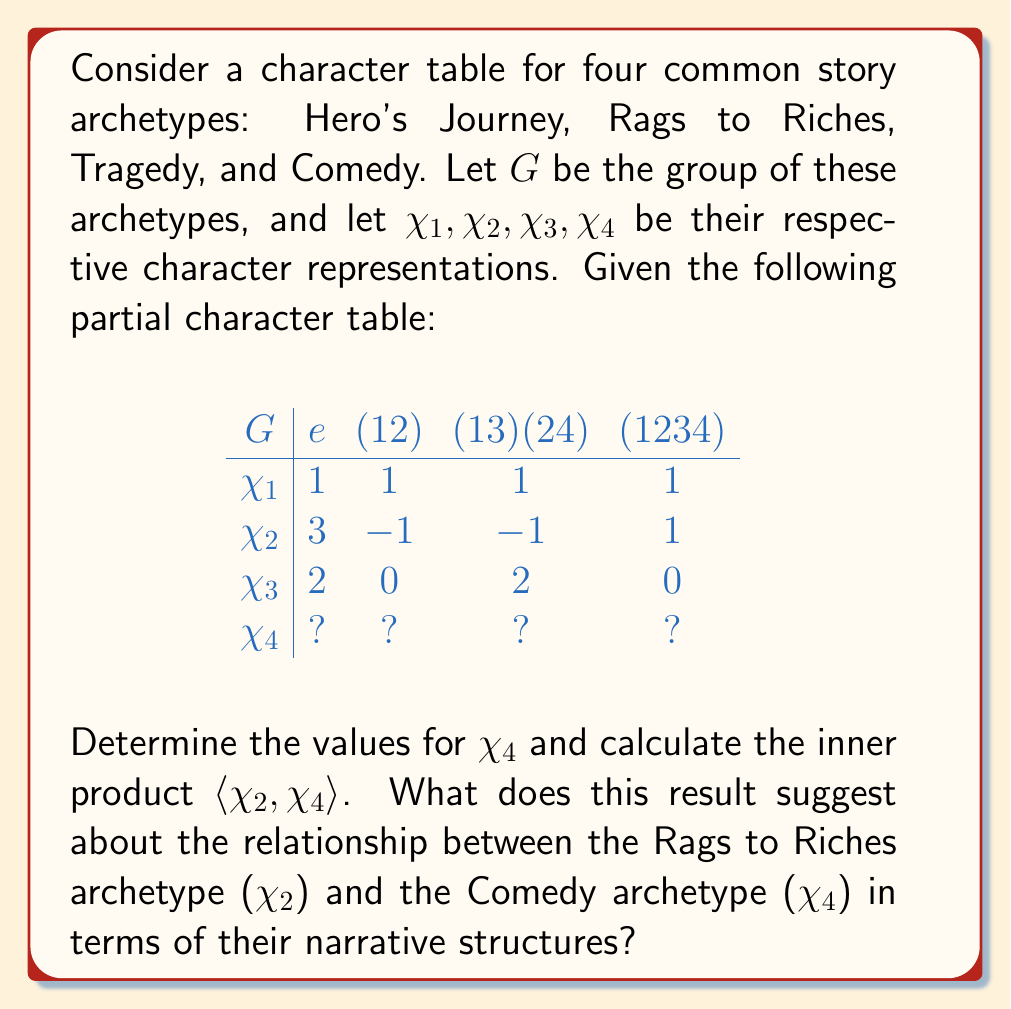Can you answer this question? To solve this problem, we'll follow these steps:

1) First, we need to complete the character table for $\chi_4$. We can do this using the orthogonality relations of characters:

   a) The sum of squares of the dimensions of irreducible representations equals the order of the group:
      $1^2 + 3^2 + 2^2 + (\chi_4(e))^2 = |G| = 4$
      So, $\chi_4(e) = 2$

   b) The sum of characters in each column (except the first) must be zero:
      For (12): $1 + (-1) + 0 + \chi_4((12)) = 0$, so $\chi_4((12)) = 0$
      For (13)(24): $1 + (-1) + 2 + \chi_4((13)(24)) = 0$, so $\chi_4((13)(24)) = -2$
      For (1234): $1 + 1 + 0 + \chi_4((1234)) = 0$, so $\chi_4((1234)) = -2$

2) Now we have the complete character table:

   $$
   \begin{array}{c|cccc}
   G & e & (12) & (13)(24) & (1234) \\
   \hline
   \chi_1 & 1 & 1 & 1 & 1 \\
   \chi_2 & 3 & -1 & -1 & 1 \\
   \chi_3 & 2 & 0 & 2 & 0 \\
   \chi_4 & 2 & 0 & -2 & -2 \\
   \end{array}
   $$

3) To calculate the inner product $\langle \chi_2, \chi_4 \rangle$, we use the formula:
   
   $\langle \chi_2, \chi_4 \rangle = \frac{1}{|G|} \sum_{g \in G} \chi_2(g) \overline{\chi_4(g)}$

4) Applying this formula:
   
   $\langle \chi_2, \chi_4 \rangle = \frac{1}{4}[(3 \cdot 2) + (-1 \cdot 0) + (-1 \cdot -2) + (1 \cdot -2)]$
   
   $= \frac{1}{4}[6 + 0 + 2 - 2] = \frac{6}{4} = \frac{3}{2}$

5) The non-zero inner product suggests that $\chi_2$ and $\chi_4$ are not orthogonal, implying that the Rags to Riches and Comedy archetypes share some common narrative structures or elements.
Answer: $\langle \chi_2, \chi_4 \rangle = \frac{3}{2}$, indicating shared narrative elements between Rags to Riches and Comedy archetypes. 